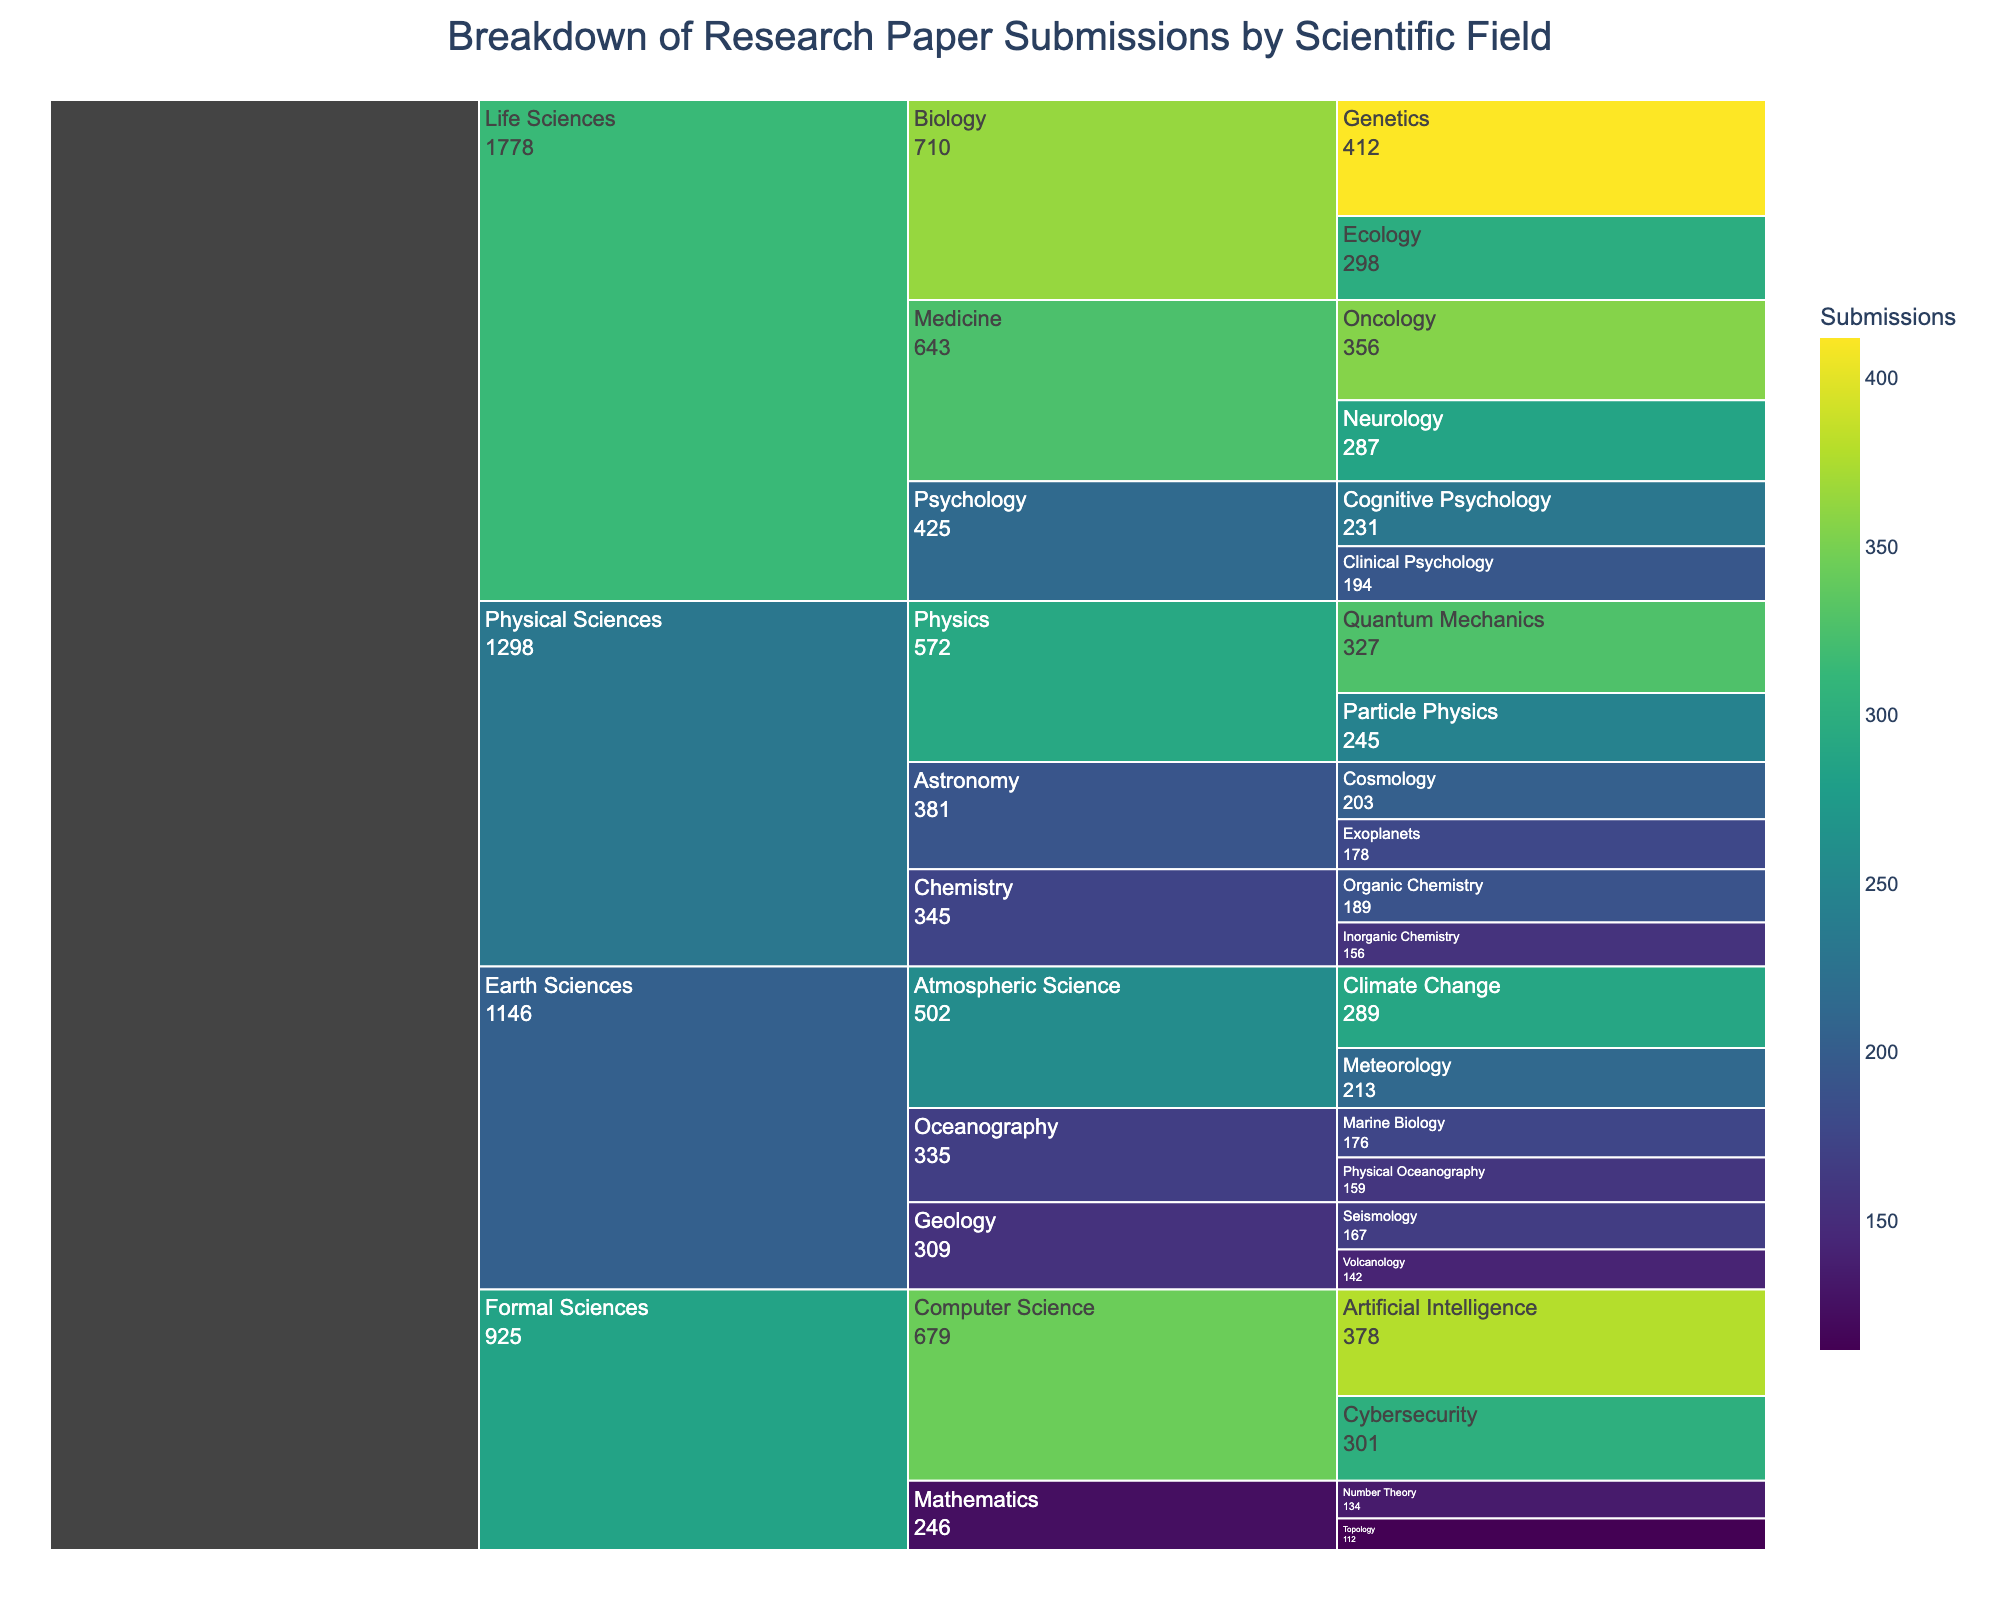What is the title of the icicle chart? The title can be found directly at the top of the figure, summarizing the content of the chart in a single phrase. The title is "Breakdown of Research Paper Submissions by Scientific Field".
Answer: Breakdown of Research Paper Submissions by Scientific Field Which category has the highest number of submissions? To determine which category has the highest number of submissions, identify the category with the largest value. From the chart, "Genetics" under "Biology" in "Life Sciences" has the highest submissions with 412.
Answer: Genetics Compare the total submissions for Life Sciences and Physical Sciences. Which has more, and by how much? Sum the submissions for all categories under Life Sciences and Physical Sciences. Life Sciences: 412 + 298 + 356 + 287 + 231 + 194 = 1,778. Physical Sciences: 327 + 245 + 189 + 156 + 203 + 178 = 1,298. Life Sciences has more by 480 submissions.
Answer: Life Sciences by 480 How many submissions are there in the field of Earth Sciences? Sum the submissions for all the sub-categories within Earth Sciences. This requires adding up all the values shown for sub-categories under Earth Sciences: 167 + 142 + 289 + 213 + 176 + 159 = 1,146.
Answer: 1,146 Which has more submissions: "Cybersecurity" or "Neurology"? Compare the values for these sub-categories. "Cybersecurity" has 301 submissions and "Neurology" has 287 submissions.
Answer: Cybersecurity What is the total number of submissions for sub-fields under Mathematics? Sum the submissions for the sub-categories under Mathematics, which are "Number Theory" and "Topology". So, 134 + 112 = 246.
Answer: 246 How does the number of submissions in "Oncology" compare to the total submissions in "Psychology"? Sum the submissions for the categories under Psychology (Cognitive Psychology and Clinical Psychology) and compare it with the submissions in Oncology. Psychology: 231 + 194 = 425. Oncology: 356. Oncology has fewer submissions by 69.
Answer: Oncology by 69 What percentage of total submissions does the field of Computer Science represent? First, sum the total submissions: 1,298 (Physical Sciences) + 1,778 (Life Sciences) + 1,146 (Earth Sciences) + 246 (Mathematics) + 679 (Computer Science) = 5,147. Then calculate the percentage: (679 / 5,147) * 100 ≈ 13.19%.
Answer: 13.19% Rank the sub-fields of Chemistry by the number of submissions. Compare the submissions in "Organic Chemistry" (189) and "Inorganic Chemistry" (156), and order them. "Organic Chemistry" has more submissions than "Inorganic Chemistry".
Answer: Organic Chemistry > Inorganic Chemistry Which sub-field in Atmospheric Science has more submissions: "Climate Change" or "Meteorology"? Compare the submissions for both sub-categories. "Climate Change" has 289 submissions, and "Meteorology" has 213.
Answer: Climate Change 